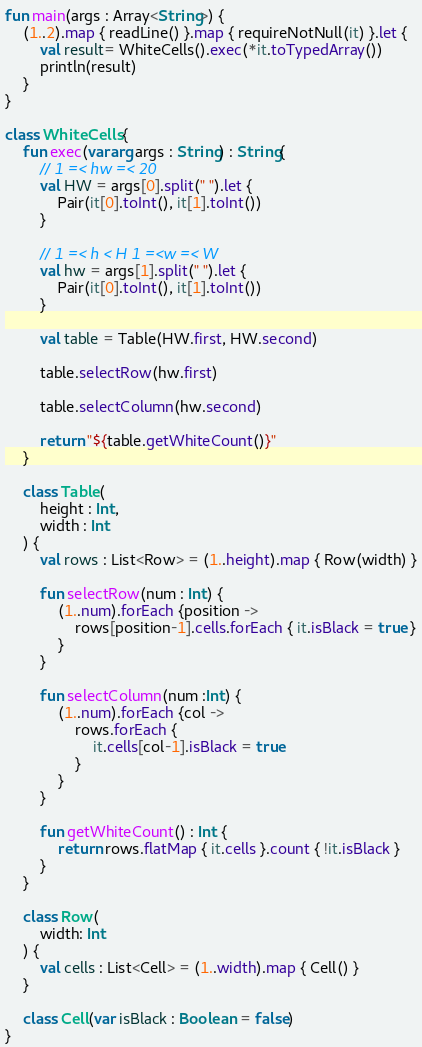<code> <loc_0><loc_0><loc_500><loc_500><_Kotlin_>fun main(args : Array<String>) {
    (1..2).map { readLine() }.map { requireNotNull(it) }.let {
        val result= WhiteCells().exec(*it.toTypedArray())
        println(result)
    }
}

class WhiteCells {
    fun exec(vararg args : String) : String{
        // 1 =< hw =< 20
        val HW = args[0].split(" ").let {
            Pair(it[0].toInt(), it[1].toInt())
        }

        // 1 =< h < H 1 =<w =< W
        val hw = args[1].split(" ").let {
            Pair(it[0].toInt(), it[1].toInt())
        }

        val table = Table(HW.first, HW.second)

        table.selectRow(hw.first)

        table.selectColumn(hw.second)

        return "${table.getWhiteCount()}"
    }

    class Table(
        height : Int,
        width : Int
    ) {
        val rows : List<Row> = (1..height).map { Row(width) }

        fun selectRow(num : Int) {
            (1..num).forEach {position ->
                rows[position-1].cells.forEach { it.isBlack = true }
            }
        }

        fun selectColumn(num :Int) {
            (1..num).forEach {col ->
                rows.forEach {
                    it.cells[col-1].isBlack = true
                }
            }
        }

        fun getWhiteCount() : Int {
            return rows.flatMap { it.cells }.count { !it.isBlack }
        }
    }

    class Row(
        width: Int
    ) {
        val cells : List<Cell> = (1..width).map { Cell() }
    }

    class Cell(var isBlack : Boolean = false)
}</code> 